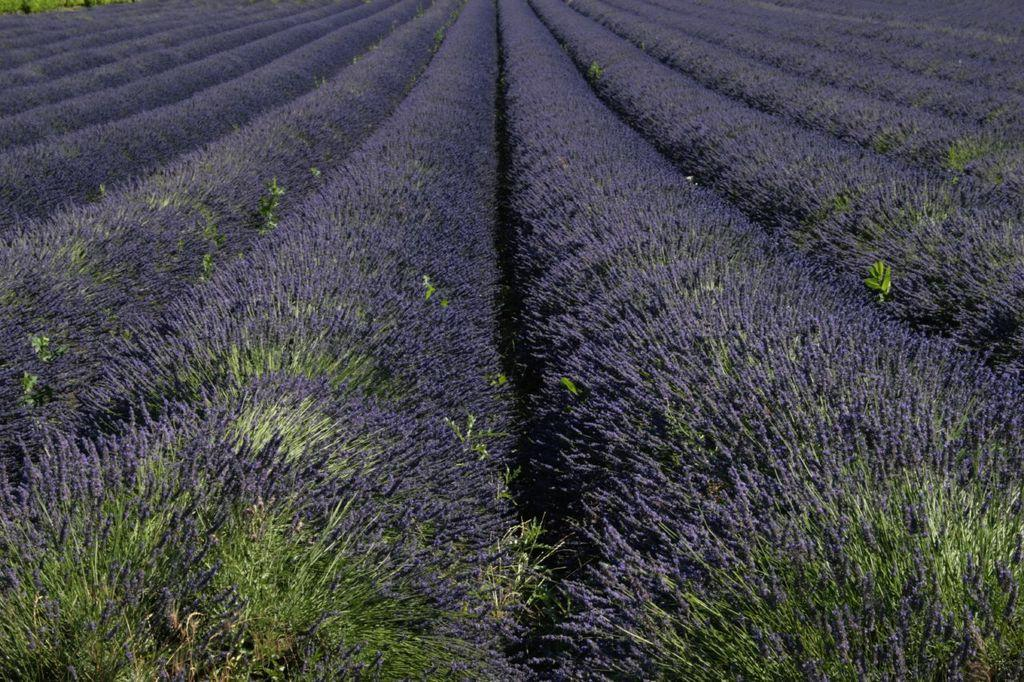What type of plants can be seen in the foreground of the image? There are lavender colored plants in the foreground of the image. How many bananas are hanging from the plants in the image? There are no bananas present in the image; it features lavender colored plants. 